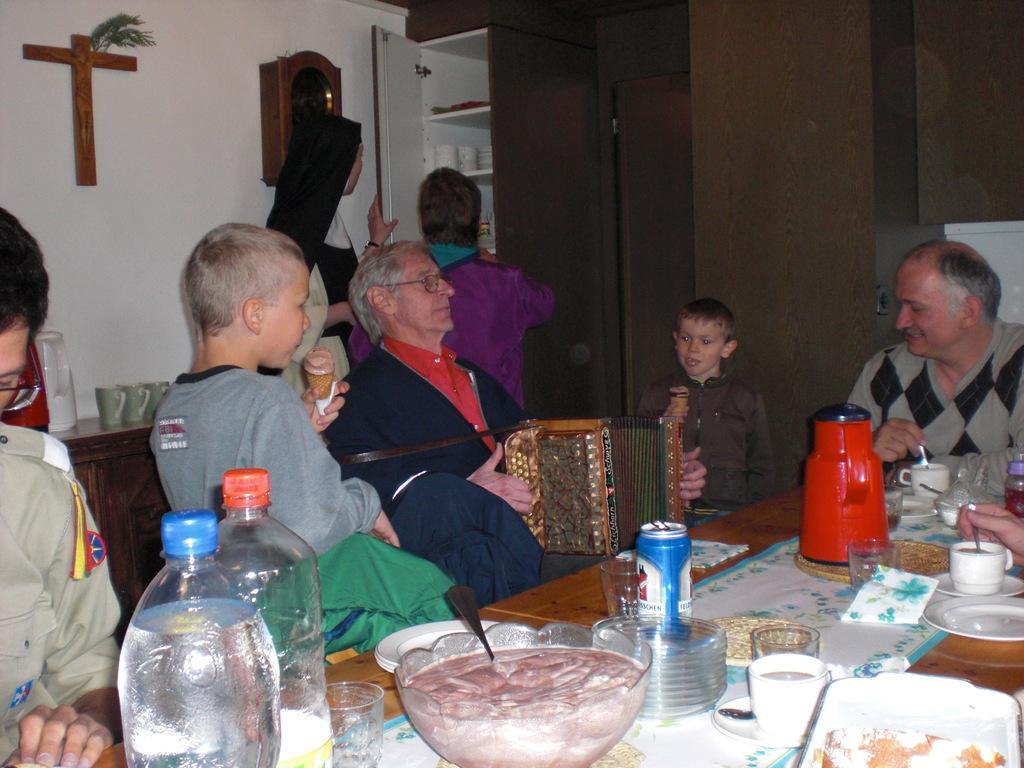Please provide a concise description of this image. The picture is clicked inside a house where people are sitting on the dining table and food items are on top of it. In the background we can also observe brown color containers. 